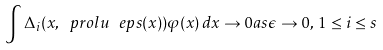Convert formula to latex. <formula><loc_0><loc_0><loc_500><loc_500>\int \Delta _ { i } ( x , \ p r o l u _ { \ } e p s ( x ) ) \varphi ( x ) \, d x \rightarrow 0 a s \epsilon \rightarrow 0 , \, 1 \leq i \leq s</formula> 